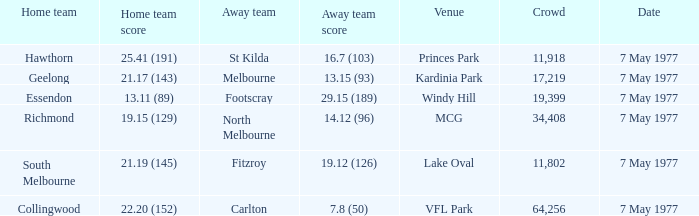Identify the location with a resident team from geelong. Kardinia Park. 